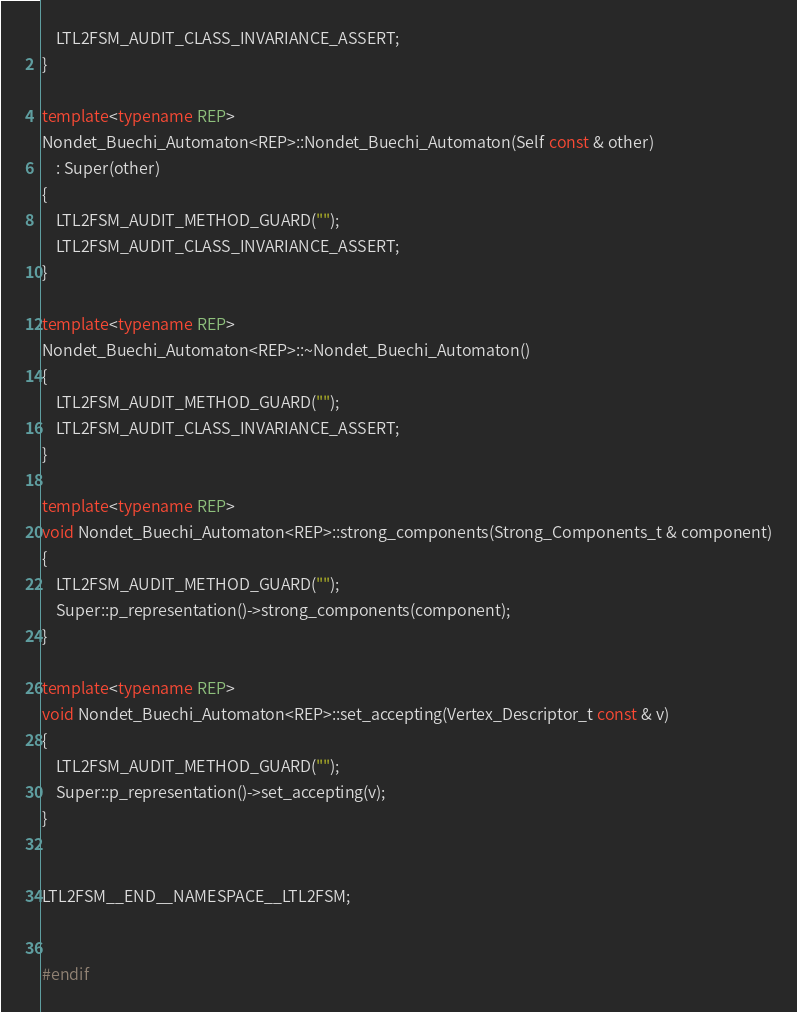<code> <loc_0><loc_0><loc_500><loc_500><_C++_>    LTL2FSM_AUDIT_CLASS_INVARIANCE_ASSERT;
}

template<typename REP>
Nondet_Buechi_Automaton<REP>::Nondet_Buechi_Automaton(Self const & other)
    : Super(other)
{
    LTL2FSM_AUDIT_METHOD_GUARD("");
    LTL2FSM_AUDIT_CLASS_INVARIANCE_ASSERT;
}

template<typename REP>
Nondet_Buechi_Automaton<REP>::~Nondet_Buechi_Automaton()
{
    LTL2FSM_AUDIT_METHOD_GUARD("");
    LTL2FSM_AUDIT_CLASS_INVARIANCE_ASSERT;
}

template<typename REP>
void Nondet_Buechi_Automaton<REP>::strong_components(Strong_Components_t & component)
{
    LTL2FSM_AUDIT_METHOD_GUARD("");
    Super::p_representation()->strong_components(component);
}

template<typename REP>
void Nondet_Buechi_Automaton<REP>::set_accepting(Vertex_Descriptor_t const & v)
{
    LTL2FSM_AUDIT_METHOD_GUARD("");
    Super::p_representation()->set_accepting(v);
}


LTL2FSM__END__NAMESPACE__LTL2FSM;


#endif
</code> 